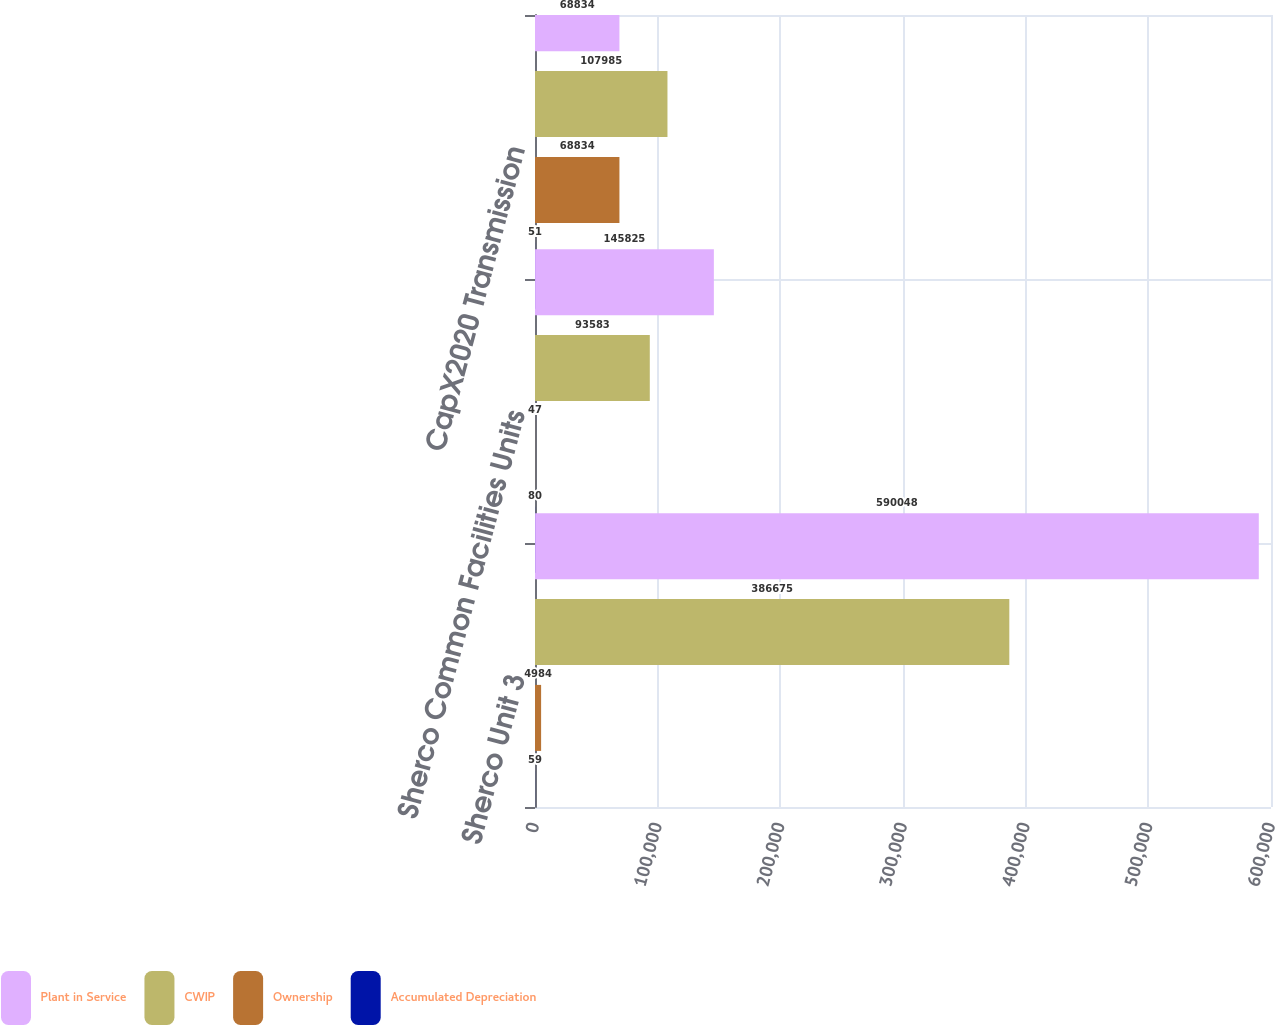<chart> <loc_0><loc_0><loc_500><loc_500><stacked_bar_chart><ecel><fcel>Sherco Unit 3<fcel>Sherco Common Facilities Units<fcel>CapX2020 Transmission<nl><fcel>Plant in Service<fcel>590048<fcel>145825<fcel>68834<nl><fcel>CWIP<fcel>386675<fcel>93583<fcel>107985<nl><fcel>Ownership<fcel>4984<fcel>47<fcel>68834<nl><fcel>Accumulated Depreciation<fcel>59<fcel>80<fcel>51<nl></chart> 